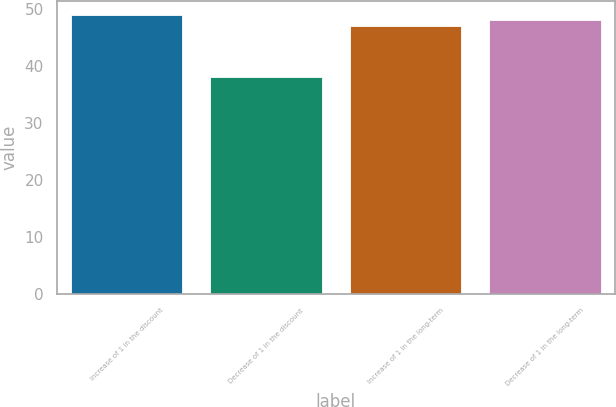Convert chart. <chart><loc_0><loc_0><loc_500><loc_500><bar_chart><fcel>Increase of 1 in the discount<fcel>Decrease of 1 in the discount<fcel>Increase of 1 in the long-term<fcel>Decrease of 1 in the long-term<nl><fcel>49<fcel>38<fcel>47<fcel>48<nl></chart> 